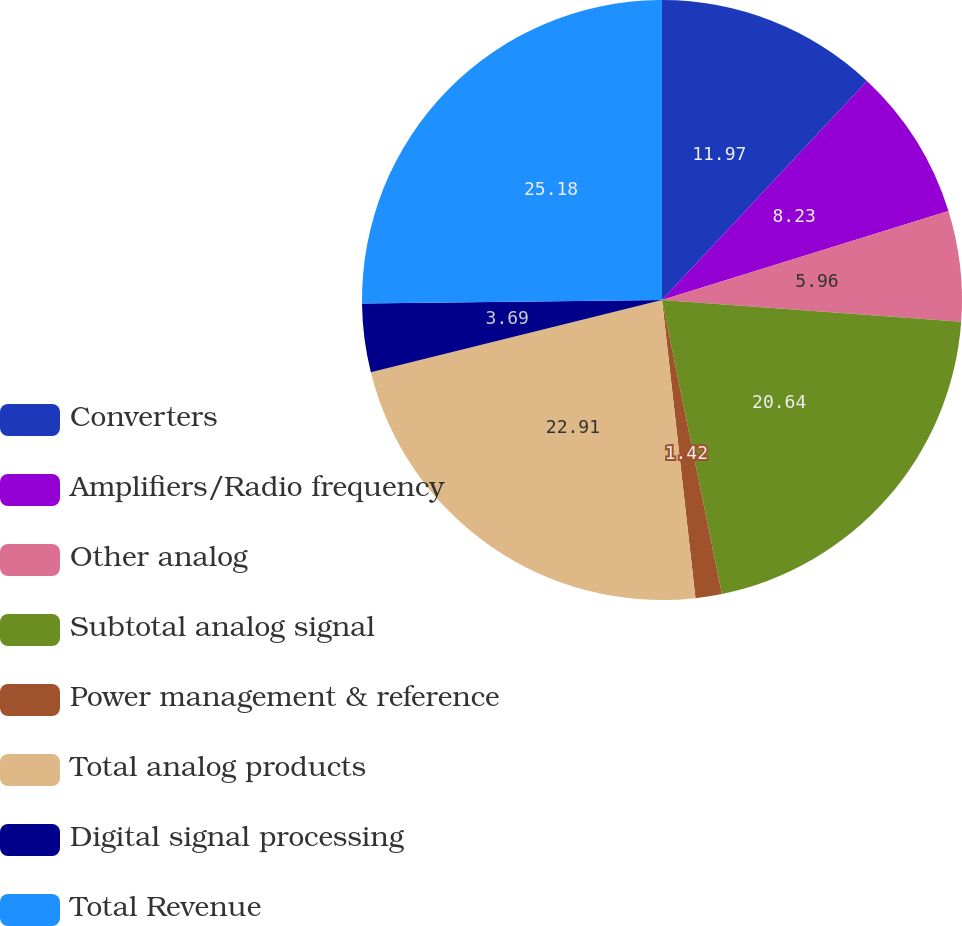Convert chart to OTSL. <chart><loc_0><loc_0><loc_500><loc_500><pie_chart><fcel>Converters<fcel>Amplifiers/Radio frequency<fcel>Other analog<fcel>Subtotal analog signal<fcel>Power management & reference<fcel>Total analog products<fcel>Digital signal processing<fcel>Total Revenue<nl><fcel>11.97%<fcel>8.23%<fcel>5.96%<fcel>20.64%<fcel>1.42%<fcel>22.91%<fcel>3.69%<fcel>25.18%<nl></chart> 